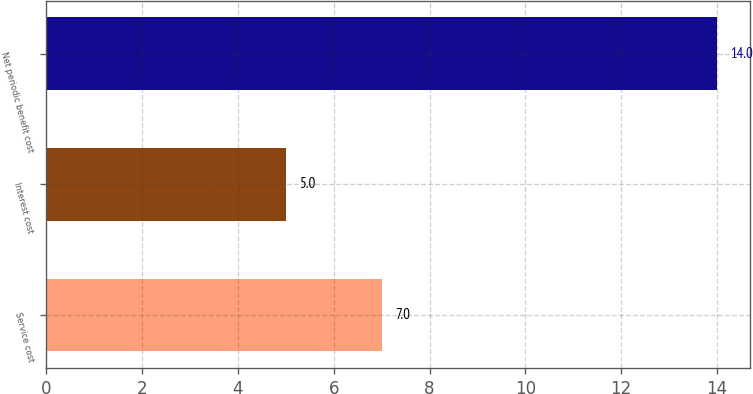Convert chart. <chart><loc_0><loc_0><loc_500><loc_500><bar_chart><fcel>Service cost<fcel>Interest cost<fcel>Net periodic benefit cost<nl><fcel>7<fcel>5<fcel>14<nl></chart> 